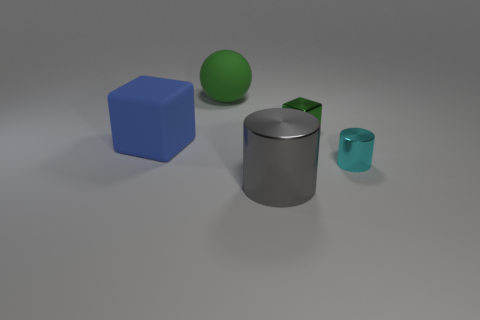There is a object on the left side of the big matte object that is behind the rubber block; how many tiny things are in front of it?
Your answer should be compact. 1. What is the size of the object that is the same color as the big rubber sphere?
Provide a short and direct response. Small. Are there any big blue matte cubes right of the big shiny cylinder?
Give a very brief answer. No. What is the shape of the small cyan shiny object?
Your answer should be very brief. Cylinder. The green object that is to the left of the big thing in front of the cylinder that is behind the gray object is what shape?
Provide a short and direct response. Sphere. What number of other objects are there of the same shape as the large green matte object?
Provide a short and direct response. 0. What is the material of the green object left of the shiny object that is on the left side of the green shiny object?
Offer a terse response. Rubber. Are there any other things that are the same size as the cyan metallic object?
Your answer should be very brief. Yes. Does the tiny green block have the same material as the large sphere that is behind the metal block?
Keep it short and to the point. No. There is a object that is both behind the blue cube and in front of the green ball; what is it made of?
Offer a terse response. Metal. 